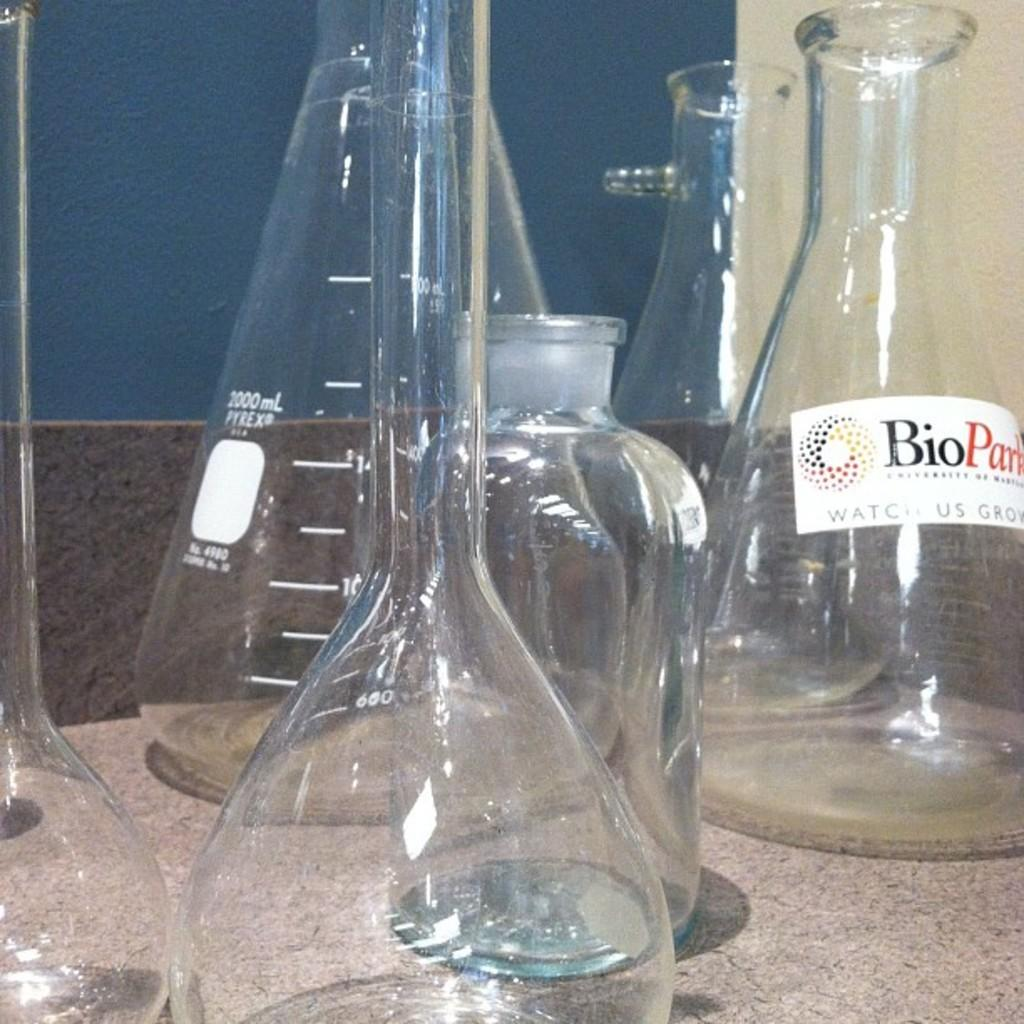<image>
Relay a brief, clear account of the picture shown. a few glasses and one with a Bio word on it 